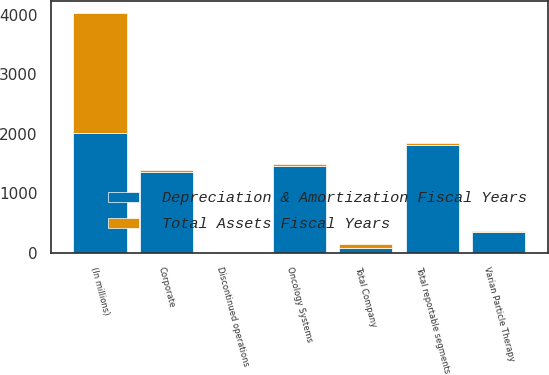Convert chart. <chart><loc_0><loc_0><loc_500><loc_500><stacked_bar_chart><ecel><fcel>(In millions)<fcel>Oncology Systems<fcel>Varian Particle Therapy<fcel>Total reportable segments<fcel>Corporate<fcel>Discontinued operations<fcel>Total Company<nl><fcel>Total Assets Fiscal Years<fcel>2017<fcel>39.4<fcel>6.1<fcel>45.5<fcel>24.8<fcel>6.6<fcel>76.9<nl><fcel>Depreciation & Amortization Fiscal Years<fcel>2017<fcel>1452.7<fcel>354.4<fcel>1807.1<fcel>1361.2<fcel>11.1<fcel>76.9<nl></chart> 